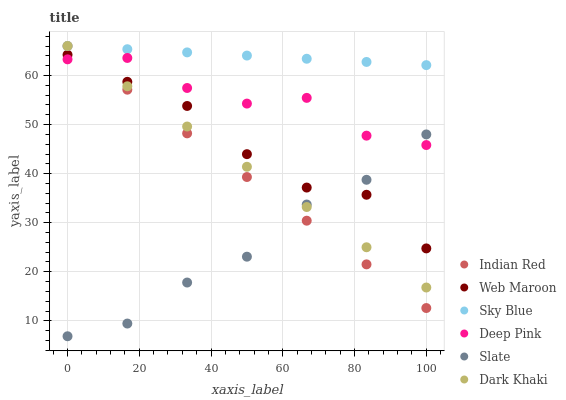Does Slate have the minimum area under the curve?
Answer yes or no. Yes. Does Sky Blue have the maximum area under the curve?
Answer yes or no. Yes. Does Web Maroon have the minimum area under the curve?
Answer yes or no. No. Does Web Maroon have the maximum area under the curve?
Answer yes or no. No. Is Dark Khaki the smoothest?
Answer yes or no. Yes. Is Deep Pink the roughest?
Answer yes or no. Yes. Is Slate the smoothest?
Answer yes or no. No. Is Slate the roughest?
Answer yes or no. No. Does Slate have the lowest value?
Answer yes or no. Yes. Does Web Maroon have the lowest value?
Answer yes or no. No. Does Sky Blue have the highest value?
Answer yes or no. Yes. Does Web Maroon have the highest value?
Answer yes or no. No. Is Web Maroon less than Sky Blue?
Answer yes or no. Yes. Is Sky Blue greater than Deep Pink?
Answer yes or no. Yes. Does Indian Red intersect Slate?
Answer yes or no. Yes. Is Indian Red less than Slate?
Answer yes or no. No. Is Indian Red greater than Slate?
Answer yes or no. No. Does Web Maroon intersect Sky Blue?
Answer yes or no. No. 